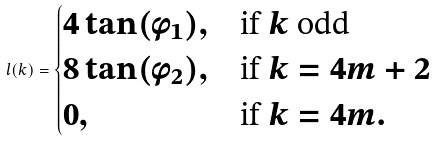Convert formula to latex. <formula><loc_0><loc_0><loc_500><loc_500>l ( k ) = \begin{cases} 4 \tan ( \phi _ { 1 } ) , & \text {if $k$ odd} \\ 8 \tan ( \phi _ { 2 } ) , & \text {if } k = 4 m + 2 \\ 0 , & \text {if } k = 4 m . \end{cases}</formula> 